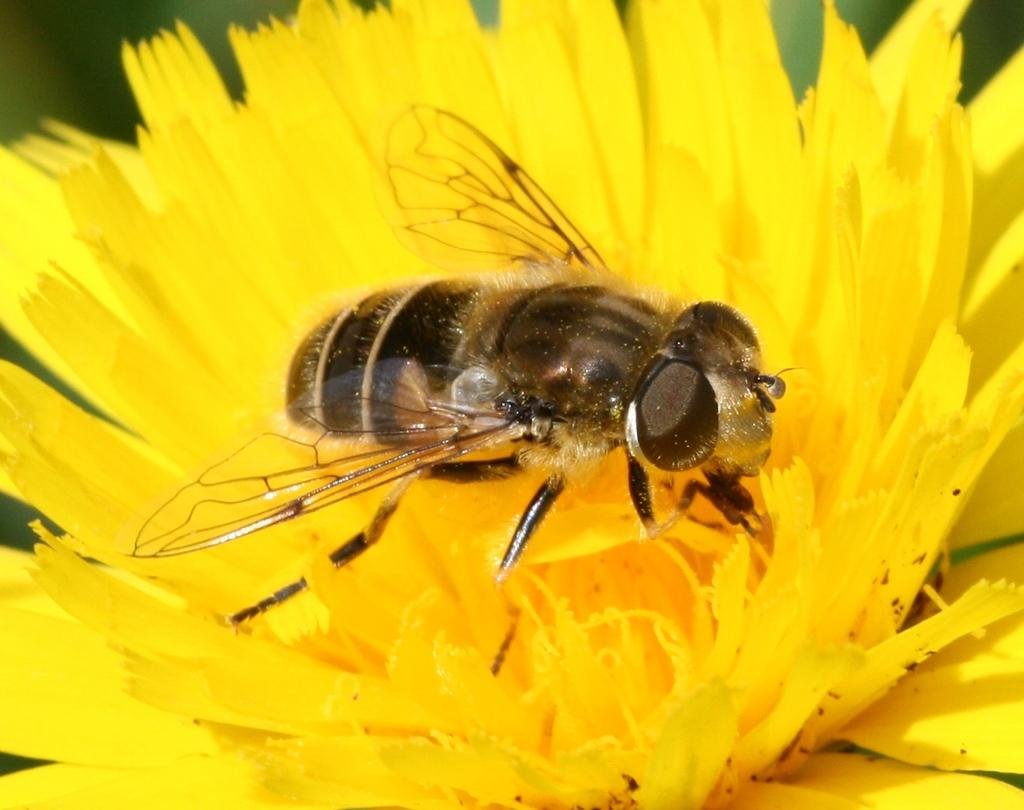What type of insect is in the image? There is a honey bee in the image. What is the honey bee doing in the image? The honey bee is sitting on a sunflower. What color is the sunflower that the honey bee is sitting on? The sunflower is yellow in color. How does the honey bee stitch the sunflower in the image? Honey bees do not have the ability to stitch, as they are insects and do not possess the necessary tools or skills for sewing. 